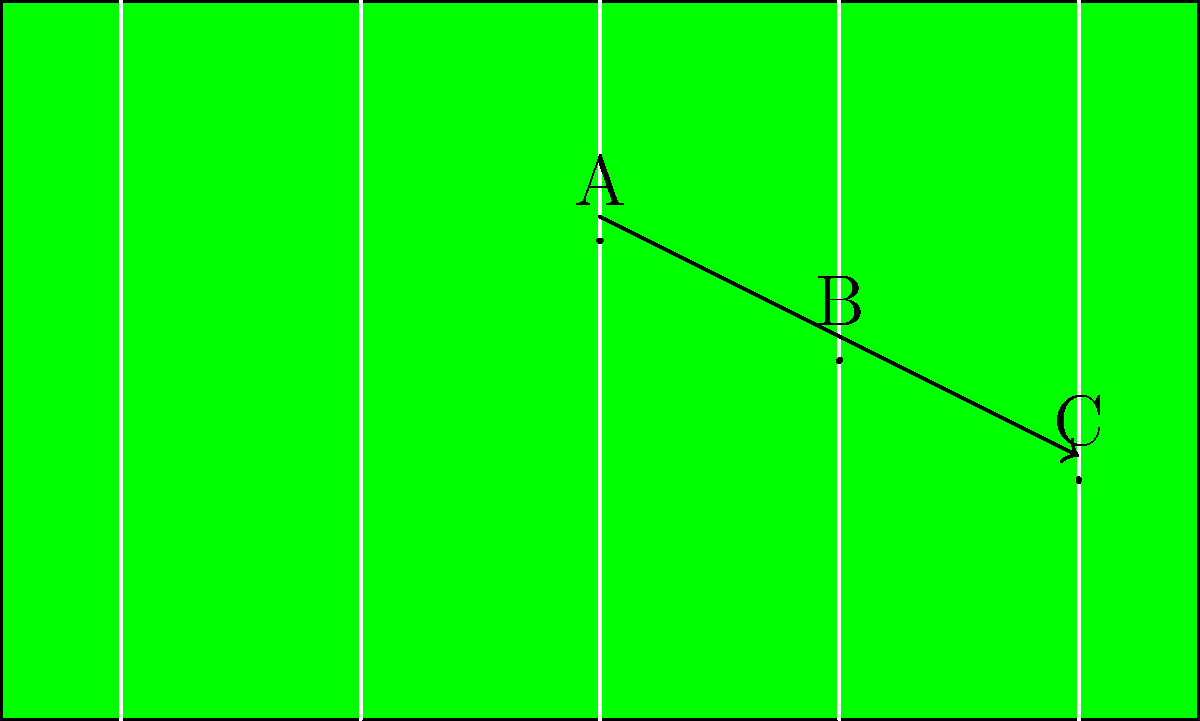During a crucial punt in the Ohio State vs. Michigan game, the Buckeyes' punter kicks the ball with an initial angular velocity of 10 rad/s. Assuming the ball's angular velocity decreases linearly due to air resistance, and at point C it has an angular velocity of 4 rad/s, what is the angular velocity of the football at point B? Let's approach this step-by-step:

1) We're given that the angular velocity decreases linearly. This means we can use the equation of a straight line: $y = mx + b$, where $m$ is the slope and $b$ is the y-intercept.

2) In our case, $y$ represents the angular velocity, and $x$ represents the position (A, B, or C).

3) We know two points on this line:
   At A (let's call this x = 0): y = 10 rad/s
   At C (let's call this x = 2): y = 4 rad/s

4) We can find the slope:
   $m = \frac{y_2 - y_1}{x_2 - x_1} = \frac{4 - 10}{2 - 0} = -3$ rad/s per unit

5) Now we can find $b$ using either point. Let's use A:
   $10 = -3(0) + b$
   $b = 10$

6) Our equation is now: $y = -3x + 10$

7) Point B is halfway between A and C, so its x-value is 1.

8) We can now find the angular velocity at B:
   $y = -3(1) + 10 = 7$ rad/s

Therefore, the angular velocity at point B is 7 rad/s.
Answer: 7 rad/s 